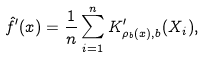<formula> <loc_0><loc_0><loc_500><loc_500>\hat { f } ^ { \prime } ( x ) = \frac { 1 } { n } \sum _ { i = 1 } ^ { n } K ^ { \prime } _ { \rho _ { b } ( x ) , b } ( X _ { i } ) ,</formula> 